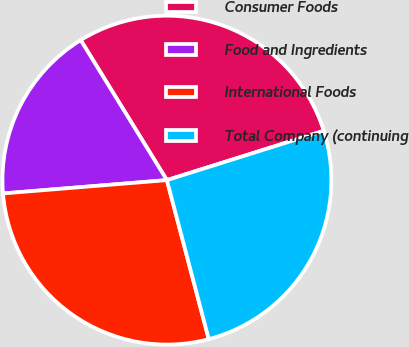Convert chart. <chart><loc_0><loc_0><loc_500><loc_500><pie_chart><fcel>Consumer Foods<fcel>Food and Ingredients<fcel>International Foods<fcel>Total Company (continuing<nl><fcel>28.94%<fcel>17.51%<fcel>27.81%<fcel>25.75%<nl></chart> 